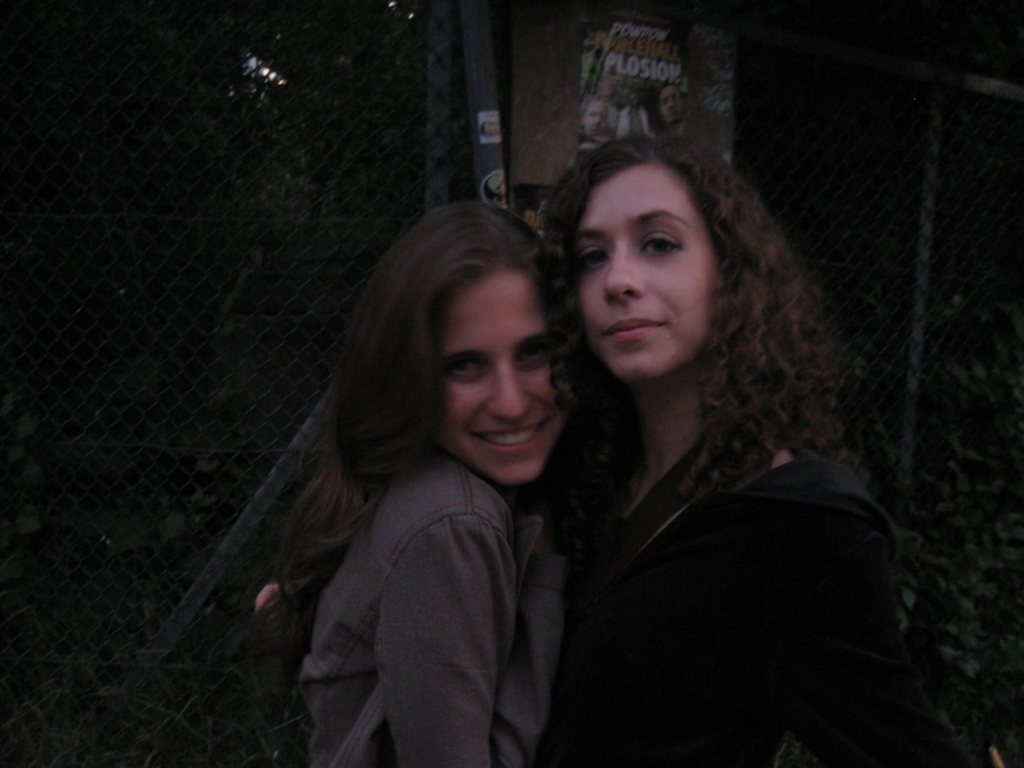What time of day does this photo appear to have been taken? The photo seems to have been taken during the evening or twilight, considering the low light levels and the appearance of artificial lighting in the background. 